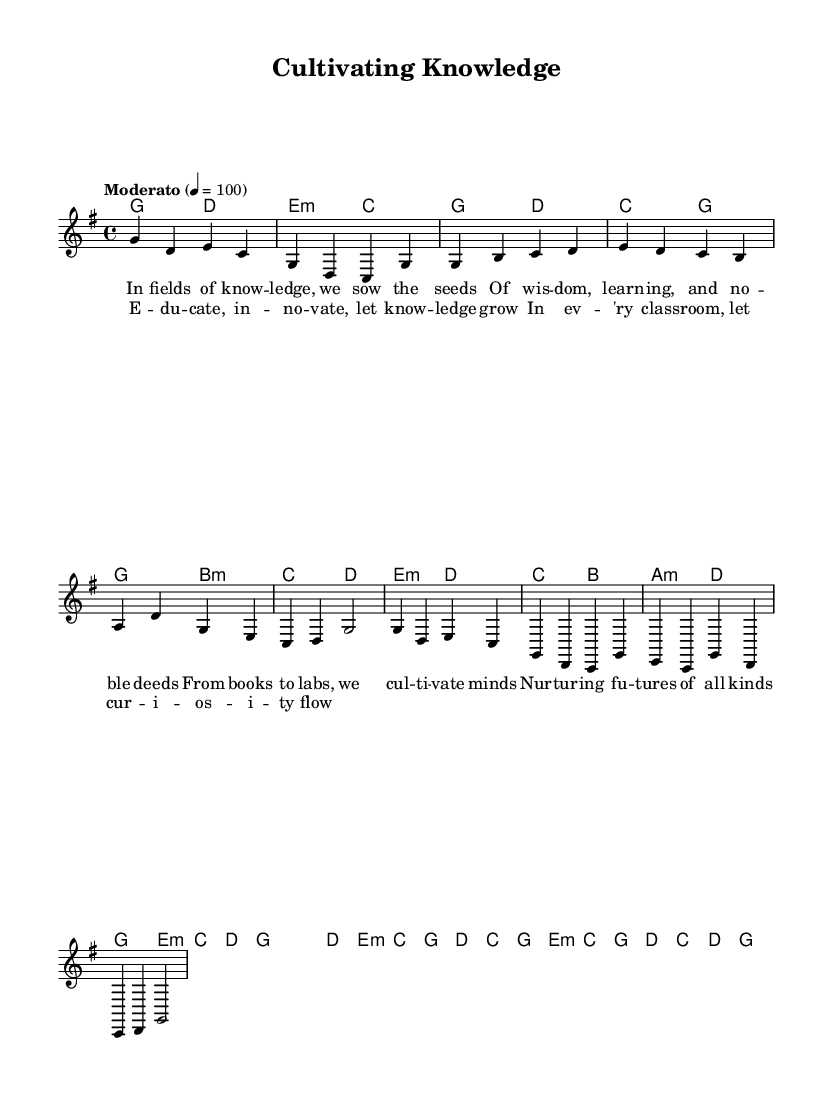What is the key signature of this music? The key signature is G major, which has one sharp (F#). This can be determined by looking at the key signature at the beginning of the staff.
Answer: G major What is the time signature of this music? The time signature is 4/4, which indicates four beats in each measure and the quarter note gets one beat. This is indicated at the beginning of the sheet music.
Answer: 4/4 What is the tempo marking for this piece? The tempo marking is "Moderato," which means moderate speed, and is set at a quarter note equals 100 beats per minute. This can be seen in the tempo instruction at the start of the music.
Answer: Moderato How many measures are in the chorus section? The chorus section has four measures. This can be identified by counting the individual measures in the chorus lyrics and music notation.
Answer: 4 Which chords are used in the verse? The chords used in the verse are G, B minor, C, D, E minor, D, C, B, A minor, D, and G. Analyzing the chords under the melody notes in the verse section provides this information.
Answer: G, B minor, C, D, E minor, D, C, B, A minor, D, G What is the main theme of the lyrics? The main theme of the lyrics focuses on education, innovation, and nurturing knowledge. This is derived from the content of the lyrics in both the verse and the chorus.
Answer: Education 